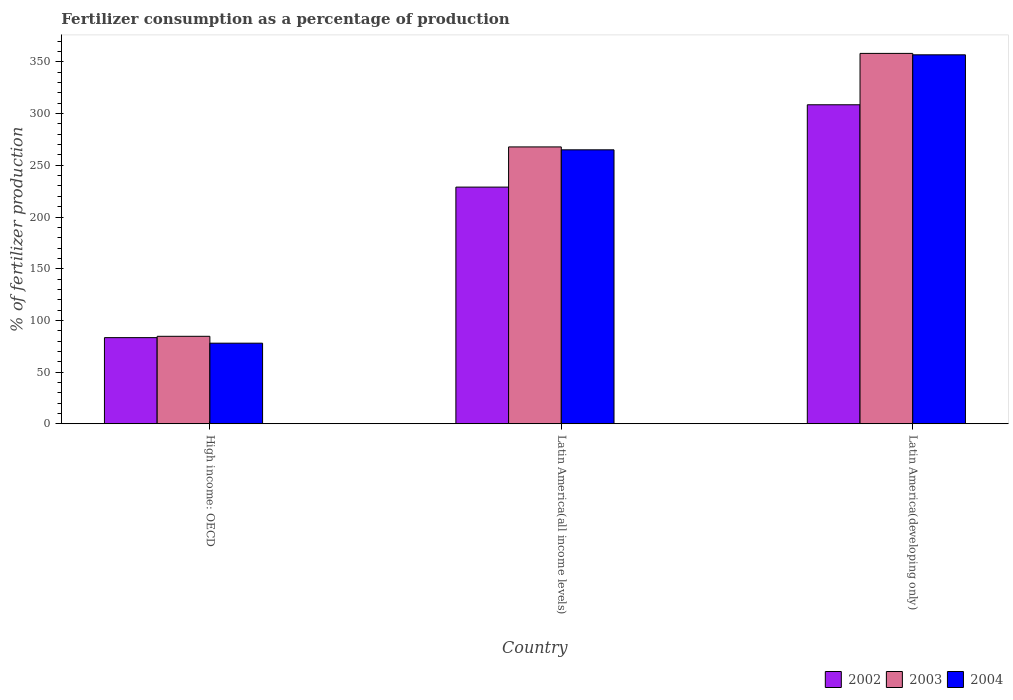How many groups of bars are there?
Your answer should be compact. 3. Are the number of bars per tick equal to the number of legend labels?
Provide a succinct answer. Yes. Are the number of bars on each tick of the X-axis equal?
Provide a succinct answer. Yes. What is the label of the 2nd group of bars from the left?
Offer a terse response. Latin America(all income levels). What is the percentage of fertilizers consumed in 2003 in Latin America(all income levels)?
Your response must be concise. 267.8. Across all countries, what is the maximum percentage of fertilizers consumed in 2003?
Provide a short and direct response. 358.28. Across all countries, what is the minimum percentage of fertilizers consumed in 2004?
Make the answer very short. 77.94. In which country was the percentage of fertilizers consumed in 2004 maximum?
Provide a succinct answer. Latin America(developing only). In which country was the percentage of fertilizers consumed in 2002 minimum?
Make the answer very short. High income: OECD. What is the total percentage of fertilizers consumed in 2003 in the graph?
Make the answer very short. 710.68. What is the difference between the percentage of fertilizers consumed in 2003 in High income: OECD and that in Latin America(developing only)?
Your response must be concise. -273.69. What is the difference between the percentage of fertilizers consumed in 2003 in Latin America(developing only) and the percentage of fertilizers consumed in 2004 in High income: OECD?
Your answer should be very brief. 280.34. What is the average percentage of fertilizers consumed in 2002 per country?
Offer a terse response. 206.94. What is the difference between the percentage of fertilizers consumed of/in 2002 and percentage of fertilizers consumed of/in 2004 in High income: OECD?
Your response must be concise. 5.36. What is the ratio of the percentage of fertilizers consumed in 2002 in High income: OECD to that in Latin America(all income levels)?
Provide a short and direct response. 0.36. What is the difference between the highest and the second highest percentage of fertilizers consumed in 2003?
Keep it short and to the point. 183.21. What is the difference between the highest and the lowest percentage of fertilizers consumed in 2004?
Provide a succinct answer. 278.97. Is the sum of the percentage of fertilizers consumed in 2004 in High income: OECD and Latin America(all income levels) greater than the maximum percentage of fertilizers consumed in 2003 across all countries?
Offer a terse response. No. What does the 1st bar from the left in High income: OECD represents?
Make the answer very short. 2002. What does the 3rd bar from the right in High income: OECD represents?
Your answer should be very brief. 2002. Are all the bars in the graph horizontal?
Make the answer very short. No. Are the values on the major ticks of Y-axis written in scientific E-notation?
Offer a very short reply. No. Where does the legend appear in the graph?
Ensure brevity in your answer.  Bottom right. How many legend labels are there?
Your response must be concise. 3. What is the title of the graph?
Ensure brevity in your answer.  Fertilizer consumption as a percentage of production. Does "2004" appear as one of the legend labels in the graph?
Your response must be concise. Yes. What is the label or title of the X-axis?
Offer a terse response. Country. What is the label or title of the Y-axis?
Provide a succinct answer. % of fertilizer production. What is the % of fertilizer production in 2002 in High income: OECD?
Offer a very short reply. 83.31. What is the % of fertilizer production of 2003 in High income: OECD?
Ensure brevity in your answer.  84.59. What is the % of fertilizer production in 2004 in High income: OECD?
Offer a very short reply. 77.94. What is the % of fertilizer production of 2002 in Latin America(all income levels)?
Ensure brevity in your answer.  228.93. What is the % of fertilizer production of 2003 in Latin America(all income levels)?
Provide a succinct answer. 267.8. What is the % of fertilizer production of 2004 in Latin America(all income levels)?
Keep it short and to the point. 264.99. What is the % of fertilizer production in 2002 in Latin America(developing only)?
Provide a short and direct response. 308.58. What is the % of fertilizer production in 2003 in Latin America(developing only)?
Make the answer very short. 358.28. What is the % of fertilizer production in 2004 in Latin America(developing only)?
Ensure brevity in your answer.  356.91. Across all countries, what is the maximum % of fertilizer production of 2002?
Provide a succinct answer. 308.58. Across all countries, what is the maximum % of fertilizer production of 2003?
Offer a very short reply. 358.28. Across all countries, what is the maximum % of fertilizer production of 2004?
Offer a terse response. 356.91. Across all countries, what is the minimum % of fertilizer production in 2002?
Give a very brief answer. 83.31. Across all countries, what is the minimum % of fertilizer production of 2003?
Your answer should be compact. 84.59. Across all countries, what is the minimum % of fertilizer production of 2004?
Give a very brief answer. 77.94. What is the total % of fertilizer production in 2002 in the graph?
Your answer should be very brief. 620.82. What is the total % of fertilizer production in 2003 in the graph?
Provide a succinct answer. 710.68. What is the total % of fertilizer production in 2004 in the graph?
Your answer should be compact. 699.84. What is the difference between the % of fertilizer production of 2002 in High income: OECD and that in Latin America(all income levels)?
Make the answer very short. -145.62. What is the difference between the % of fertilizer production in 2003 in High income: OECD and that in Latin America(all income levels)?
Make the answer very short. -183.21. What is the difference between the % of fertilizer production in 2004 in High income: OECD and that in Latin America(all income levels)?
Make the answer very short. -187.05. What is the difference between the % of fertilizer production in 2002 in High income: OECD and that in Latin America(developing only)?
Your answer should be compact. -225.27. What is the difference between the % of fertilizer production of 2003 in High income: OECD and that in Latin America(developing only)?
Offer a terse response. -273.69. What is the difference between the % of fertilizer production of 2004 in High income: OECD and that in Latin America(developing only)?
Make the answer very short. -278.97. What is the difference between the % of fertilizer production of 2002 in Latin America(all income levels) and that in Latin America(developing only)?
Ensure brevity in your answer.  -79.64. What is the difference between the % of fertilizer production in 2003 in Latin America(all income levels) and that in Latin America(developing only)?
Keep it short and to the point. -90.48. What is the difference between the % of fertilizer production of 2004 in Latin America(all income levels) and that in Latin America(developing only)?
Give a very brief answer. -91.92. What is the difference between the % of fertilizer production of 2002 in High income: OECD and the % of fertilizer production of 2003 in Latin America(all income levels)?
Ensure brevity in your answer.  -184.5. What is the difference between the % of fertilizer production of 2002 in High income: OECD and the % of fertilizer production of 2004 in Latin America(all income levels)?
Ensure brevity in your answer.  -181.68. What is the difference between the % of fertilizer production in 2003 in High income: OECD and the % of fertilizer production in 2004 in Latin America(all income levels)?
Keep it short and to the point. -180.4. What is the difference between the % of fertilizer production in 2002 in High income: OECD and the % of fertilizer production in 2003 in Latin America(developing only)?
Ensure brevity in your answer.  -274.98. What is the difference between the % of fertilizer production of 2002 in High income: OECD and the % of fertilizer production of 2004 in Latin America(developing only)?
Provide a short and direct response. -273.6. What is the difference between the % of fertilizer production in 2003 in High income: OECD and the % of fertilizer production in 2004 in Latin America(developing only)?
Keep it short and to the point. -272.31. What is the difference between the % of fertilizer production of 2002 in Latin America(all income levels) and the % of fertilizer production of 2003 in Latin America(developing only)?
Keep it short and to the point. -129.35. What is the difference between the % of fertilizer production of 2002 in Latin America(all income levels) and the % of fertilizer production of 2004 in Latin America(developing only)?
Your answer should be compact. -127.98. What is the difference between the % of fertilizer production in 2003 in Latin America(all income levels) and the % of fertilizer production in 2004 in Latin America(developing only)?
Your response must be concise. -89.11. What is the average % of fertilizer production of 2002 per country?
Give a very brief answer. 206.94. What is the average % of fertilizer production in 2003 per country?
Provide a succinct answer. 236.89. What is the average % of fertilizer production in 2004 per country?
Your answer should be very brief. 233.28. What is the difference between the % of fertilizer production of 2002 and % of fertilizer production of 2003 in High income: OECD?
Your response must be concise. -1.29. What is the difference between the % of fertilizer production of 2002 and % of fertilizer production of 2004 in High income: OECD?
Your response must be concise. 5.36. What is the difference between the % of fertilizer production in 2003 and % of fertilizer production in 2004 in High income: OECD?
Keep it short and to the point. 6.65. What is the difference between the % of fertilizer production of 2002 and % of fertilizer production of 2003 in Latin America(all income levels)?
Your answer should be very brief. -38.87. What is the difference between the % of fertilizer production of 2002 and % of fertilizer production of 2004 in Latin America(all income levels)?
Make the answer very short. -36.06. What is the difference between the % of fertilizer production in 2003 and % of fertilizer production in 2004 in Latin America(all income levels)?
Ensure brevity in your answer.  2.81. What is the difference between the % of fertilizer production of 2002 and % of fertilizer production of 2003 in Latin America(developing only)?
Ensure brevity in your answer.  -49.71. What is the difference between the % of fertilizer production of 2002 and % of fertilizer production of 2004 in Latin America(developing only)?
Your answer should be compact. -48.33. What is the difference between the % of fertilizer production in 2003 and % of fertilizer production in 2004 in Latin America(developing only)?
Your answer should be very brief. 1.38. What is the ratio of the % of fertilizer production of 2002 in High income: OECD to that in Latin America(all income levels)?
Keep it short and to the point. 0.36. What is the ratio of the % of fertilizer production in 2003 in High income: OECD to that in Latin America(all income levels)?
Offer a terse response. 0.32. What is the ratio of the % of fertilizer production of 2004 in High income: OECD to that in Latin America(all income levels)?
Ensure brevity in your answer.  0.29. What is the ratio of the % of fertilizer production of 2002 in High income: OECD to that in Latin America(developing only)?
Your answer should be compact. 0.27. What is the ratio of the % of fertilizer production in 2003 in High income: OECD to that in Latin America(developing only)?
Ensure brevity in your answer.  0.24. What is the ratio of the % of fertilizer production of 2004 in High income: OECD to that in Latin America(developing only)?
Keep it short and to the point. 0.22. What is the ratio of the % of fertilizer production in 2002 in Latin America(all income levels) to that in Latin America(developing only)?
Your answer should be compact. 0.74. What is the ratio of the % of fertilizer production of 2003 in Latin America(all income levels) to that in Latin America(developing only)?
Your response must be concise. 0.75. What is the ratio of the % of fertilizer production in 2004 in Latin America(all income levels) to that in Latin America(developing only)?
Provide a succinct answer. 0.74. What is the difference between the highest and the second highest % of fertilizer production of 2002?
Your response must be concise. 79.64. What is the difference between the highest and the second highest % of fertilizer production of 2003?
Your answer should be compact. 90.48. What is the difference between the highest and the second highest % of fertilizer production in 2004?
Keep it short and to the point. 91.92. What is the difference between the highest and the lowest % of fertilizer production in 2002?
Offer a very short reply. 225.27. What is the difference between the highest and the lowest % of fertilizer production in 2003?
Ensure brevity in your answer.  273.69. What is the difference between the highest and the lowest % of fertilizer production in 2004?
Your answer should be compact. 278.97. 